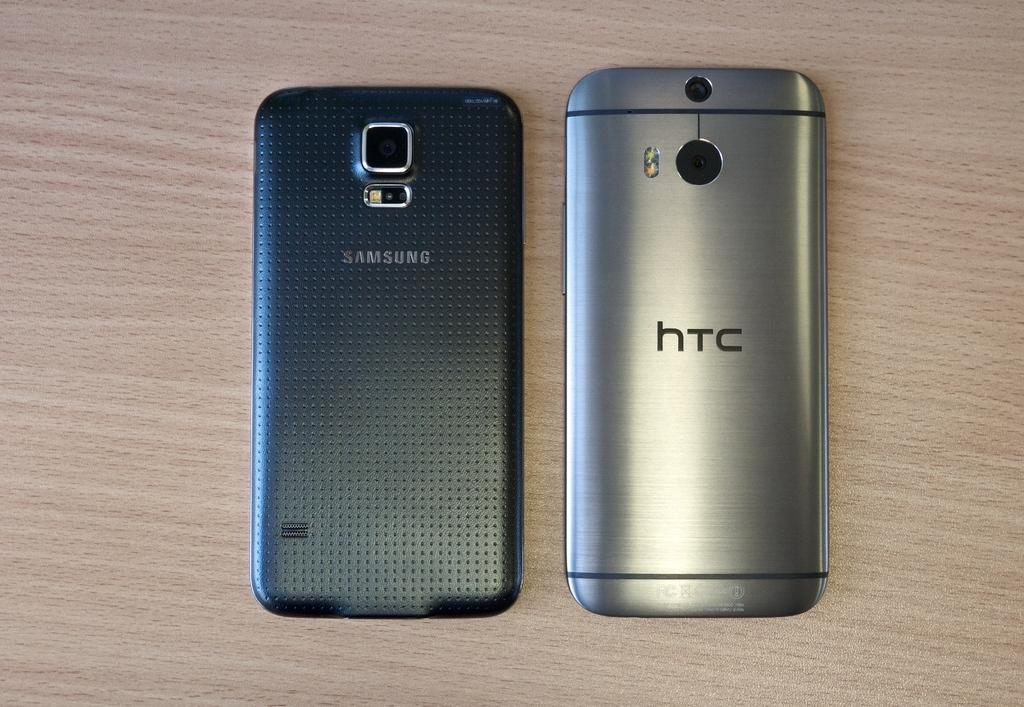<image>
Render a clear and concise summary of the photo. The back of a Samsung phone is shown next to the back of an HTC phone on a wooden surface. 